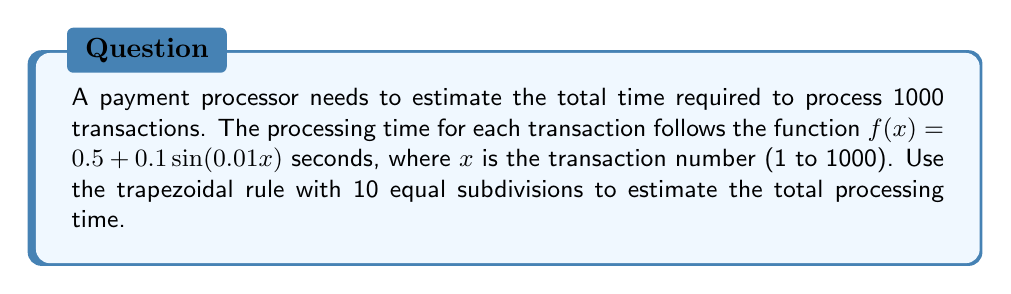Can you solve this math problem? To estimate the total processing time using the trapezoidal rule:

1. Define the integral: 
   $$\int_{1}^{1000} (0.5 + 0.1\sin(0.01x)) dx$$

2. Divide the interval [1, 1000] into 10 equal subdivisions:
   Step size $h = \frac{1000 - 1}{10} = 99.9$

3. Calculate $x_i$ values:
   $x_0 = 1$, $x_1 = 100.9$, $x_2 = 200.8$, ..., $x_{10} = 1000$

4. Apply the trapezoidal rule formula:
   $$\text{Total time} \approx \frac{h}{2}[f(x_0) + 2f(x_1) + 2f(x_2) + ... + 2f(x_9) + f(x_{10})]$$

5. Calculate function values:
   $f(x_0) = 0.5 + 0.1\sin(0.01) = 0.500998$
   $f(x_1) = 0.5 + 0.1\sin(1.009) = 0.599015$
   ...
   $f(x_{10}) = 0.5 + 0.1\sin(10) = 0.544021$

6. Sum the values:
   $$\text{Total time} \approx 49.95[0.500998 + 2(0.599015 + ... + 0.455979) + 0.544021]$$
   $$\approx 49.95 * 10.000042 = 499.502 \text{ seconds}$$
Answer: 499.502 seconds 